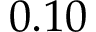<formula> <loc_0><loc_0><loc_500><loc_500>0 . 1 0</formula> 